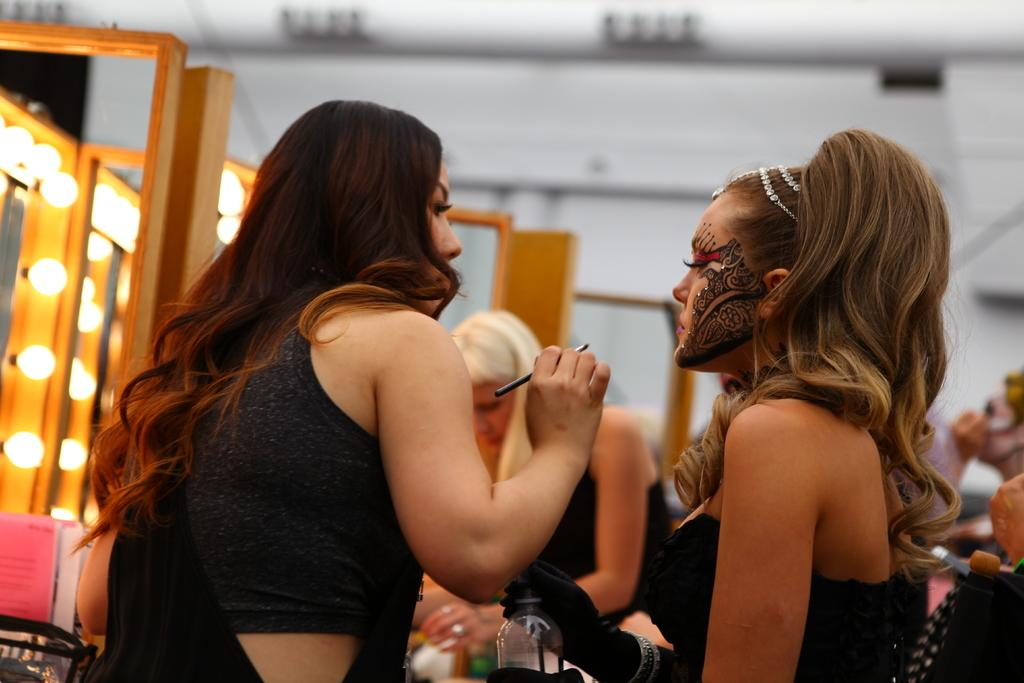Who or what can be seen in the image? There are people in the image. What is the bottle used for in the image? The purpose of the bottle is not clear from the image, but it is present. What can be seen illuminated in the image? There are lights in the image. What other objects are present in the image? There are other objects in the image, but their specific details are not mentioned in the facts. How would you describe the background of the image? The background of the image is blurry. How many spiders are crawling on the edge of the game in the image? There are no spiders or games present in the image. 